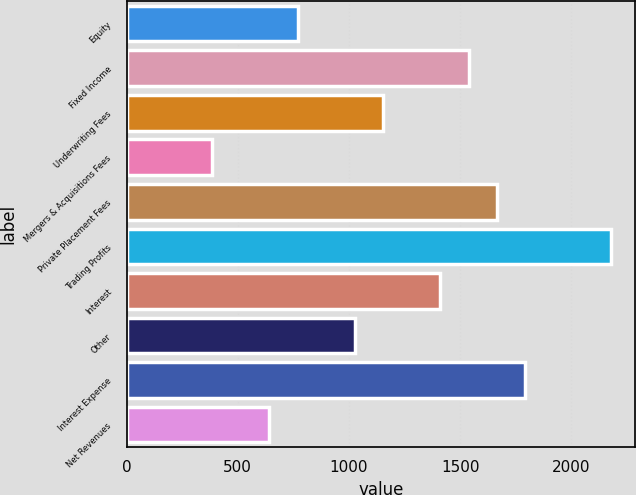Convert chart. <chart><loc_0><loc_0><loc_500><loc_500><bar_chart><fcel>Equity<fcel>Fixed Income<fcel>Underwriting Fees<fcel>Mergers & Acquisitions Fees<fcel>Private Placement Fees<fcel>Trading Profits<fcel>Interest<fcel>Other<fcel>Interest Expense<fcel>Net Revenues<nl><fcel>770<fcel>1538<fcel>1154<fcel>386<fcel>1666<fcel>2178<fcel>1410<fcel>1026<fcel>1794<fcel>642<nl></chart> 